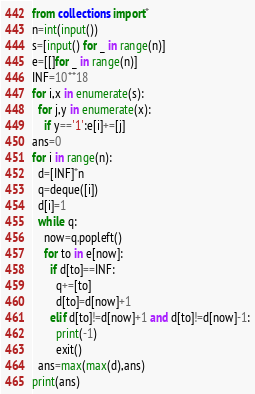<code> <loc_0><loc_0><loc_500><loc_500><_Python_>from collections import*
n=int(input())
s=[input() for _ in range(n)]
e=[[]for _ in range(n)]
INF=10**18
for i,x in enumerate(s):
  for j,y in enumerate(x):
    if y=='1':e[i]+=[j]
ans=0
for i in range(n):
  d=[INF]*n
  q=deque([i])
  d[i]=1
  while q:
    now=q.popleft()
    for to in e[now]:
      if d[to]==INF:
        q+=[to]
        d[to]=d[now]+1
      elif d[to]!=d[now]+1 and d[to]!=d[now]-1:
        print(-1)
        exit()
  ans=max(max(d),ans)
print(ans)</code> 